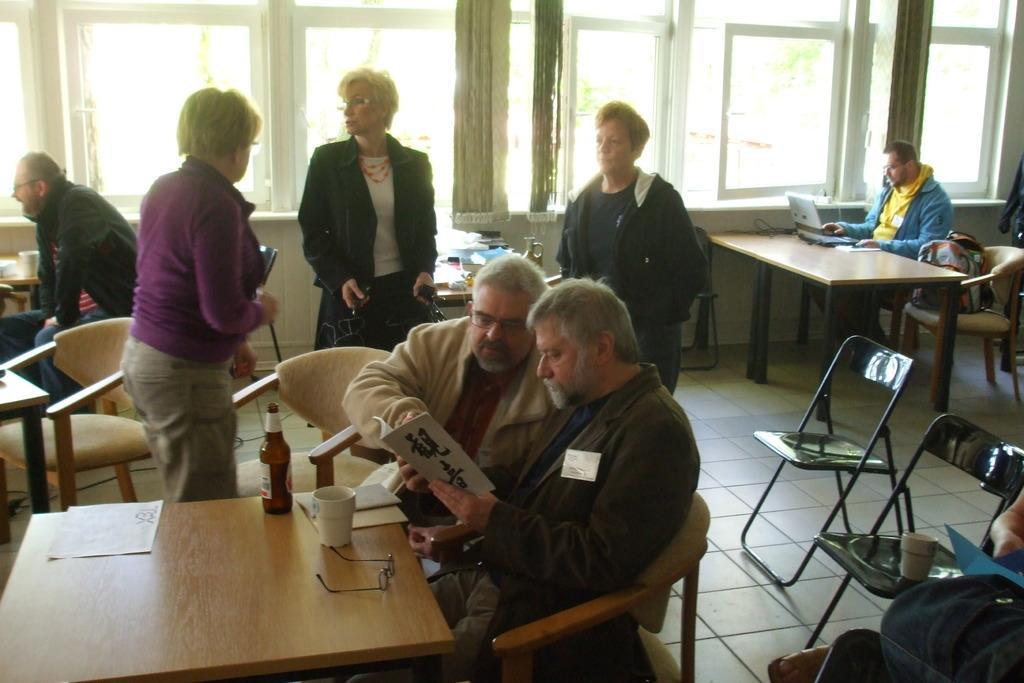Can you describe this image briefly? In this picture we can see a group of people where some are sitting on chairs and holding books in their hands and some are standing and in front of them on table we have papers, glass, cup, spectacle, laptop and in background we can see windows, bags on chairs. 